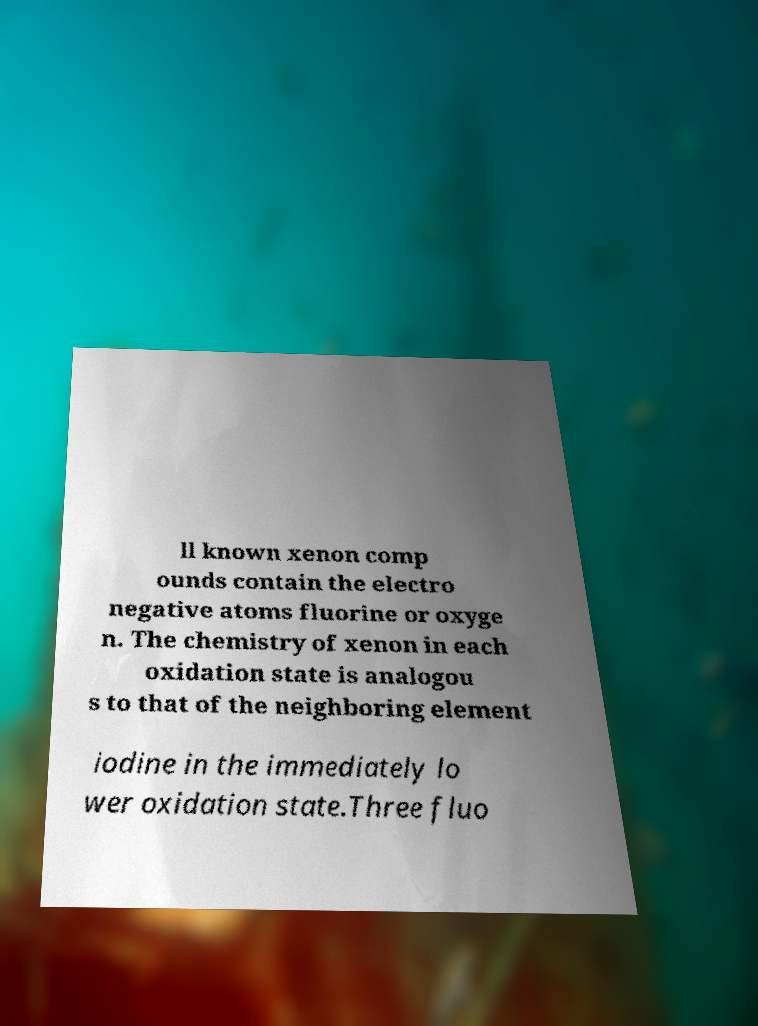Can you read and provide the text displayed in the image?This photo seems to have some interesting text. Can you extract and type it out for me? ll known xenon comp ounds contain the electro negative atoms fluorine or oxyge n. The chemistry of xenon in each oxidation state is analogou s to that of the neighboring element iodine in the immediately lo wer oxidation state.Three fluo 